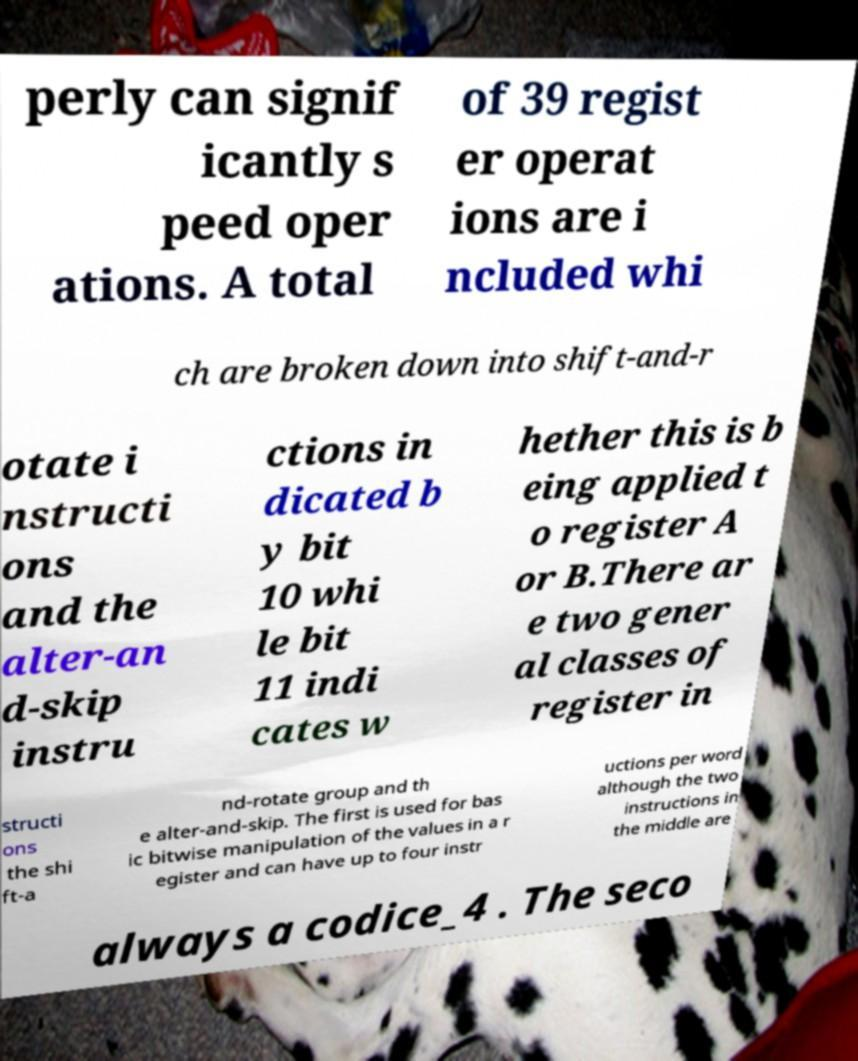Could you assist in decoding the text presented in this image and type it out clearly? perly can signif icantly s peed oper ations. A total of 39 regist er operat ions are i ncluded whi ch are broken down into shift-and-r otate i nstructi ons and the alter-an d-skip instru ctions in dicated b y bit 10 whi le bit 11 indi cates w hether this is b eing applied t o register A or B.There ar e two gener al classes of register in structi ons the shi ft-a nd-rotate group and th e alter-and-skip. The first is used for bas ic bitwise manipulation of the values in a r egister and can have up to four instr uctions per word although the two instructions in the middle are always a codice_4 . The seco 